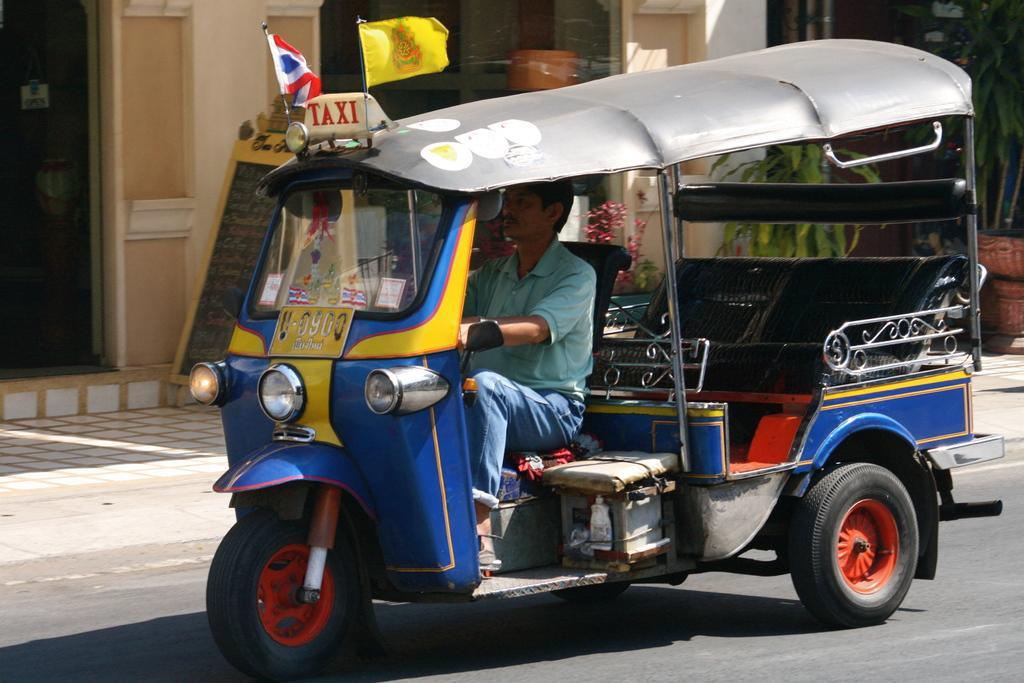Could you give a brief overview of what you see in this image? In this picture I can see there is an auto and there is a person riding it. There is a building in the backdrop with doors and windows. 